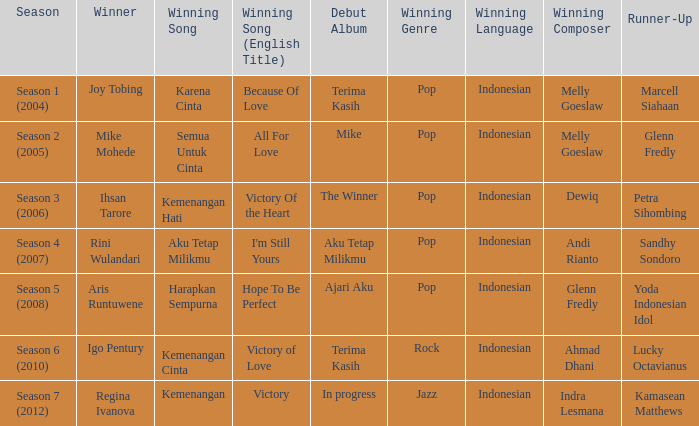Which English winning song had the winner aris runtuwene? Hope To Be Perfect. 